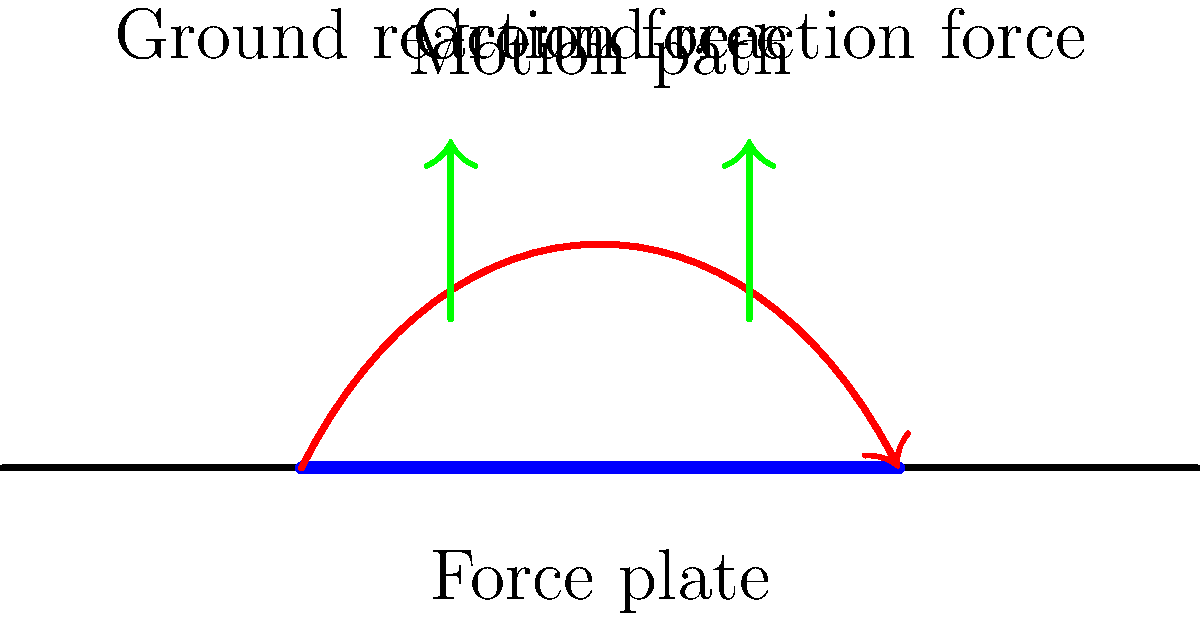In the biomechanical analysis of a character's specialized running technique, as shown in the diagram, what does the red curved path represent, and how does it relate to the efficiency of the running technique? To understand the biomechanical efficiency of the character's specialized running technique, we need to analyze the diagram step-by-step:

1. The red curved path represents the motion path of the character's center of mass during the running cycle.

2. The shape of this path is crucial for understanding the running efficiency:
   a. A flatter curve indicates less vertical displacement, which is generally more efficient.
   b. A more pronounced curve suggests higher vertical displacement, which may be less efficient due to increased energy expenditure.

3. The force plate (blue line) measures ground reaction forces during foot contact.

4. The green arrows represent the ground reaction forces at different points of contact.

5. Efficient running techniques typically aim to:
   a. Minimize vertical displacement of the center of mass.
   b. Optimize the application of ground reaction forces to propel forward motion.

6. By analyzing the relationship between the motion path and the ground reaction forces, we can assess the character's running efficiency:
   a. If the peak of the curve aligns with the highest ground reaction forces, it may indicate good energy transfer.
   b. If the motion path is relatively flat and the ground reaction forces are primarily directed backwards, it suggests an efficient forward propulsion.

7. The character's specialized technique can be evaluated by comparing this motion path and force profile to those of standard running techniques.

In conclusion, the red curved path represents the trajectory of the character's center of mass, and its shape, in conjunction with the ground reaction forces, provides crucial information about the biomechanical efficiency of the running technique.
Answer: Motion path of the center of mass, indicating running efficiency through vertical displacement and force application. 